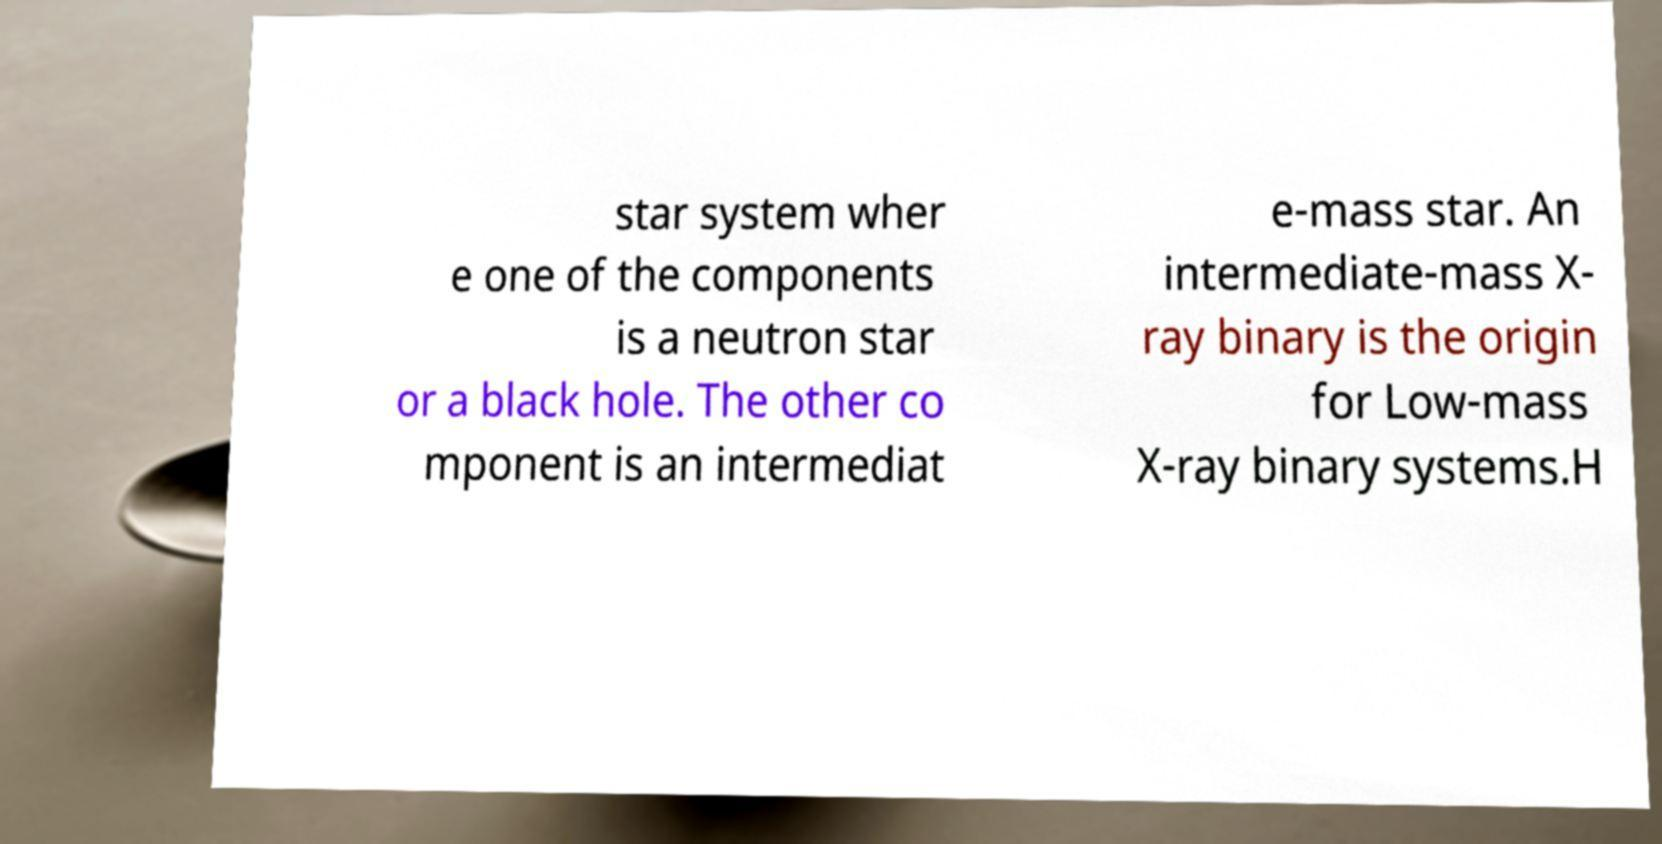I need the written content from this picture converted into text. Can you do that? star system wher e one of the components is a neutron star or a black hole. The other co mponent is an intermediat e-mass star. An intermediate-mass X- ray binary is the origin for Low-mass X-ray binary systems.H 